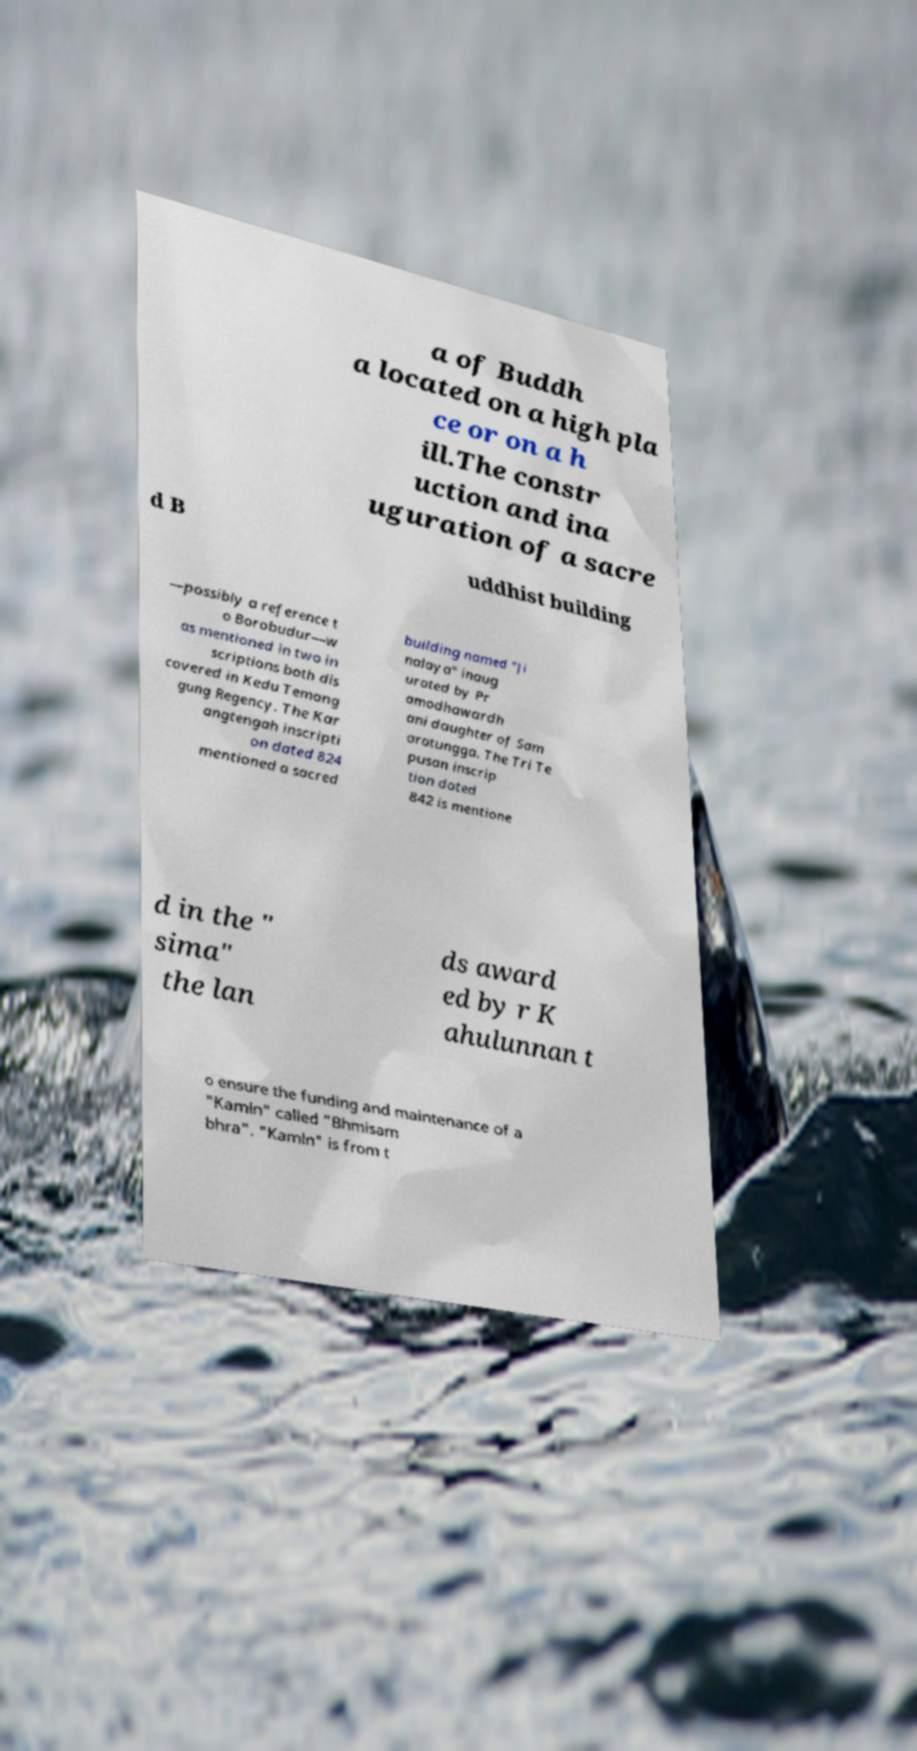For documentation purposes, I need the text within this image transcribed. Could you provide that? a of Buddh a located on a high pla ce or on a h ill.The constr uction and ina uguration of a sacre d B uddhist building —possibly a reference t o Borobudur—w as mentioned in two in scriptions both dis covered in Kedu Temang gung Regency. The Kar angtengah inscripti on dated 824 mentioned a sacred building named "Ji nalaya" inaug urated by Pr amodhawardh ani daughter of Sam aratungga. The Tri Te pusan inscrip tion dated 842 is mentione d in the " sima" the lan ds award ed by r K ahulunnan t o ensure the funding and maintenance of a "Kamln" called "Bhmisam bhra". "Kamln" is from t 